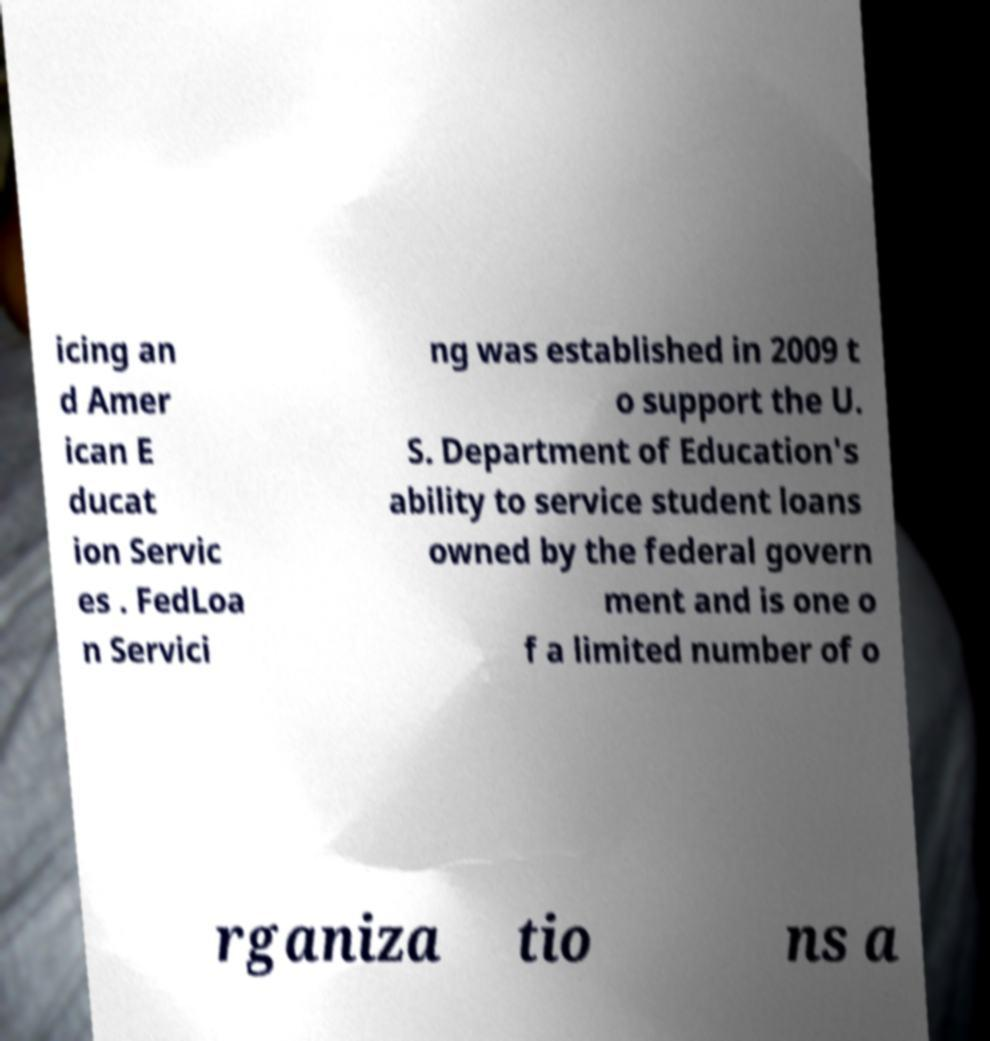Could you assist in decoding the text presented in this image and type it out clearly? icing an d Amer ican E ducat ion Servic es . FedLoa n Servici ng was established in 2009 t o support the U. S. Department of Education's ability to service student loans owned by the federal govern ment and is one o f a limited number of o rganiza tio ns a 